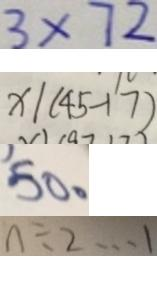Convert formula to latex. <formula><loc_0><loc_0><loc_500><loc_500>3 \times 7 2 
 x \vert ( 4 5 - 1 7 ) 
 5 0 。 
 n \div 2 \cdots 1</formula> 